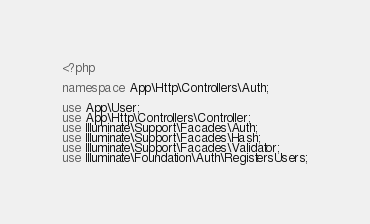Convert code to text. <code><loc_0><loc_0><loc_500><loc_500><_PHP_><?php

namespace App\Http\Controllers\Auth;

use App\User;
use App\Http\Controllers\Controller;
use Illuminate\Support\Facades\Auth;
use Illuminate\Support\Facades\Hash;
use Illuminate\Support\Facades\Validator;
use Illuminate\Foundation\Auth\RegistersUsers;
</code> 